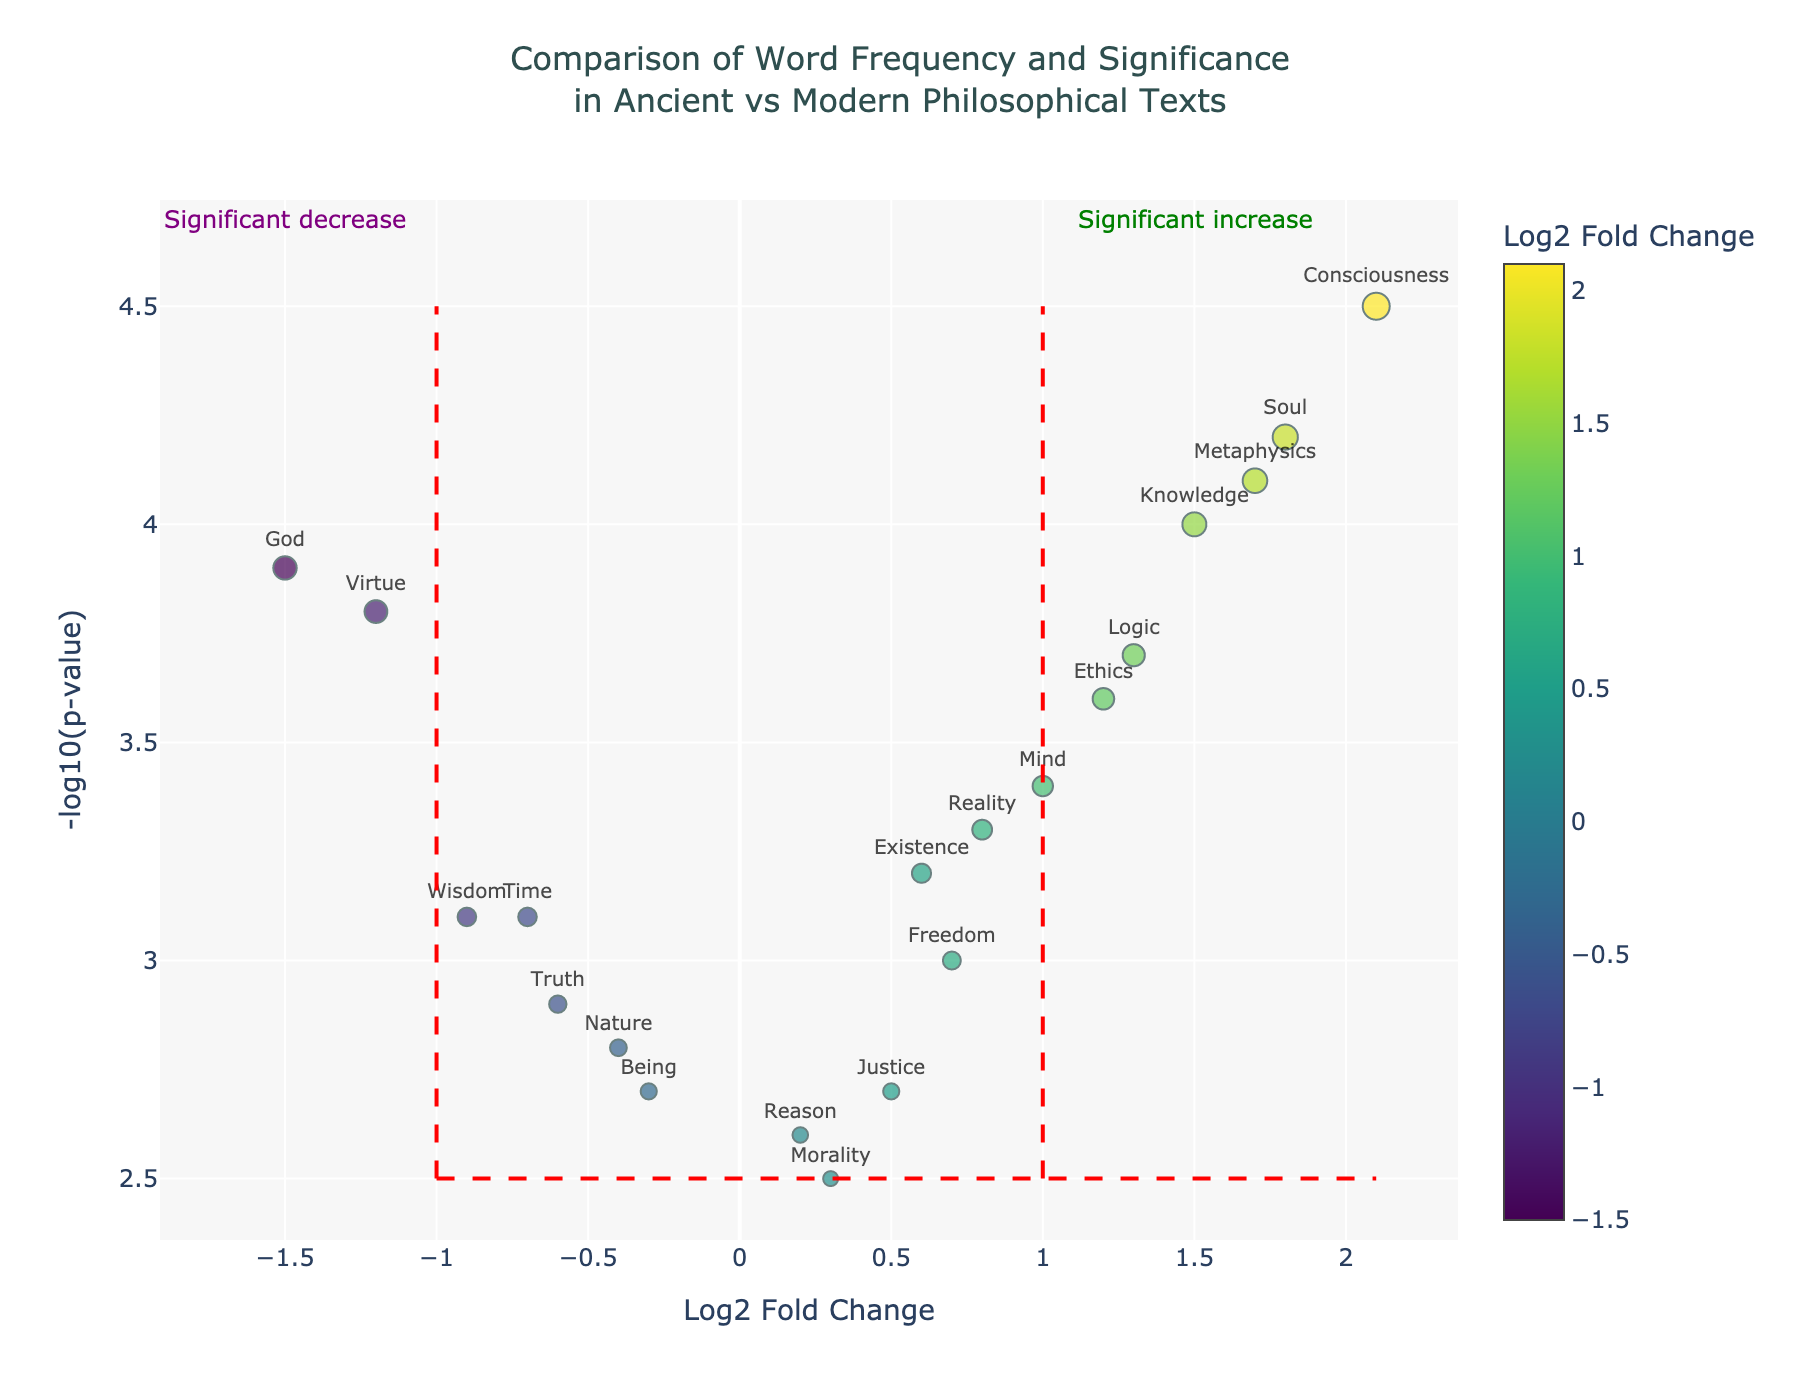What is the title of the plot? The title is located at the top of the plot, between the x and y-axis labels. It reads "Comparison of Word Frequency and Significance in Ancient vs Modern Philosophical Texts"
Answer: Comparison of Word Frequency and Significance in Ancient vs Modern Philosophical Texts Which word has the highest Log2 Fold Change in the plot? To find the word with the highest Log2 Fold Change, look at the words that are farthest to the right on the x-axis. The highest positive Log2 Fold Change is for the word 'Consciousness'
Answer: Consciousness What does the y-axis represent in this plot? The y-axis label is found vertically on the left side of the plot. It represents "-log10(p-value)"
Answer: -log10(p-value) How many words have a Log2 Fold Change greater than 1? To determine this, count the number of data points (words) that lie to the right of the x-axis value 1. The words are 'Knowledge', 'Ethics', 'Mind', 'Metaphysics', and 'Consciousness'
Answer: 5 Which two words are closest to the origin in the plot? To find the words closest to the origin (0,0), look for the points nearest the center of the plot. 'Reason' at (0.2,2.6) and 'Morality' at (0.3,2.5) are the closest.
Answer: Reason and Morality Which word has the highest significance but a negative Log2 Fold Change? Look for the word with the highest y-axis value (NegativeLogPValue) among those with negative x-axis values (Log2FoldChange). The word 'God' has the highest significance with a Negative Log2 Fold Change
Answer: God What color scale is used for the markers in the plot? Observe the color gradient for the markers. The colors range from dark to light corresponding to the Log2 Fold Change values. The color scale used is 'Viridis'
Answer: Viridis Which words fall into the "Significant increase" region as marked by the annotation? The "Significant increase" region is demarcated by lines on the plot, typically in the upper-right. The words 'Knowledge', 'Soul', 'Mind', 'Ethics', 'Logic', 'Metaphysics', 'Consciousness' fall into this region
Answer: Knowledge, Soul, Mind, Ethics, Logic, Metaphysics, Consciousness Compare the significance of 'Truth' and 'Reality'. Which one is more significant? Significance corresponds to higher values on the y-axis (-log10(p-value)). 'Truth' has a y-value of 2.9, while 'Reality' has a y-value of 3.3. Therefore, 'Reality' is more significant.
Answer: Reality What is the Log2 Fold Change for the word 'Virtue'? Find the point labeled 'Virtue' on the plot and check its x-axis value. The Log2 Fold Change for 'Virtue' is -1.2
Answer: -1.2 